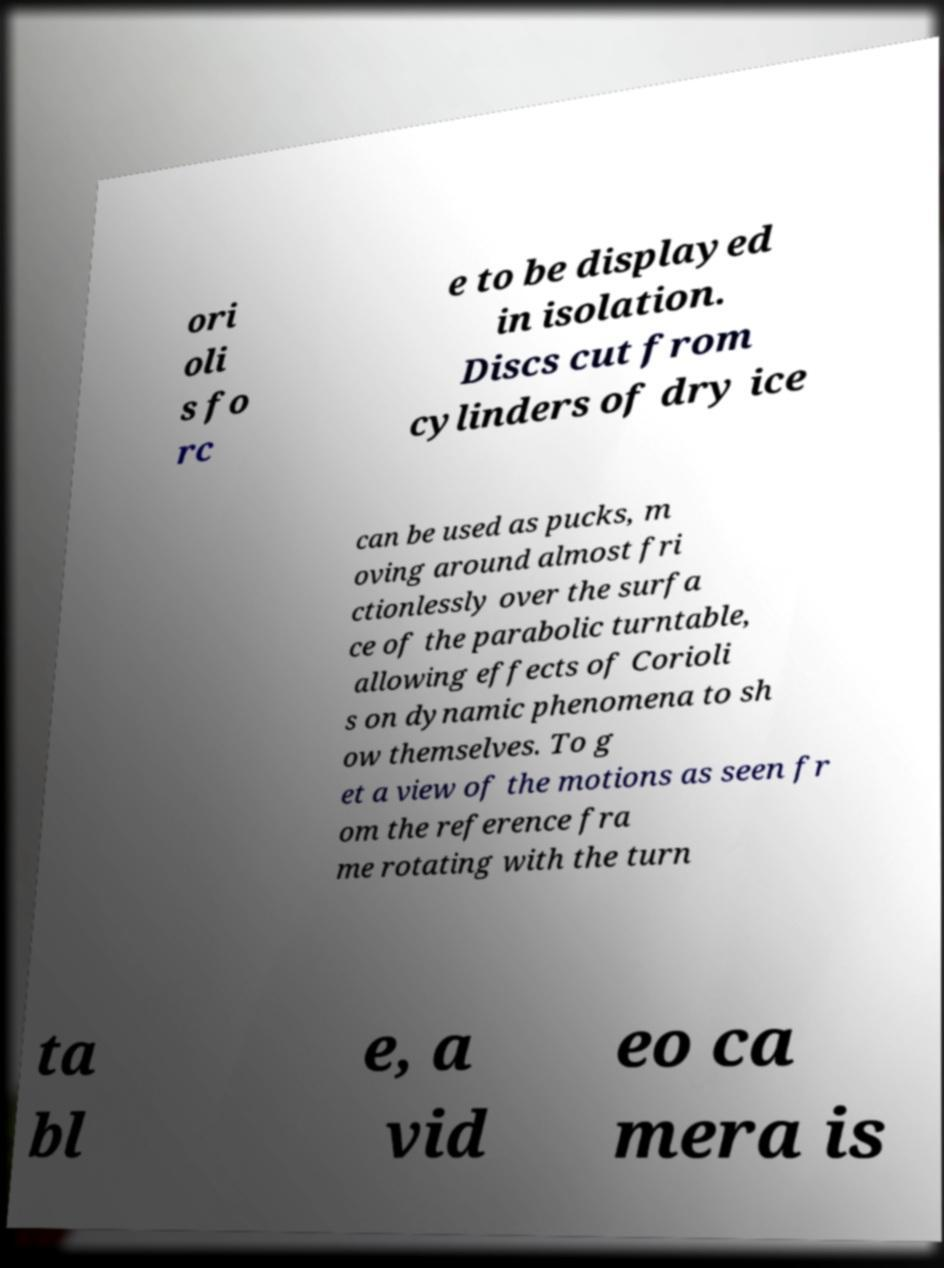Can you accurately transcribe the text from the provided image for me? ori oli s fo rc e to be displayed in isolation. Discs cut from cylinders of dry ice can be used as pucks, m oving around almost fri ctionlessly over the surfa ce of the parabolic turntable, allowing effects of Corioli s on dynamic phenomena to sh ow themselves. To g et a view of the motions as seen fr om the reference fra me rotating with the turn ta bl e, a vid eo ca mera is 